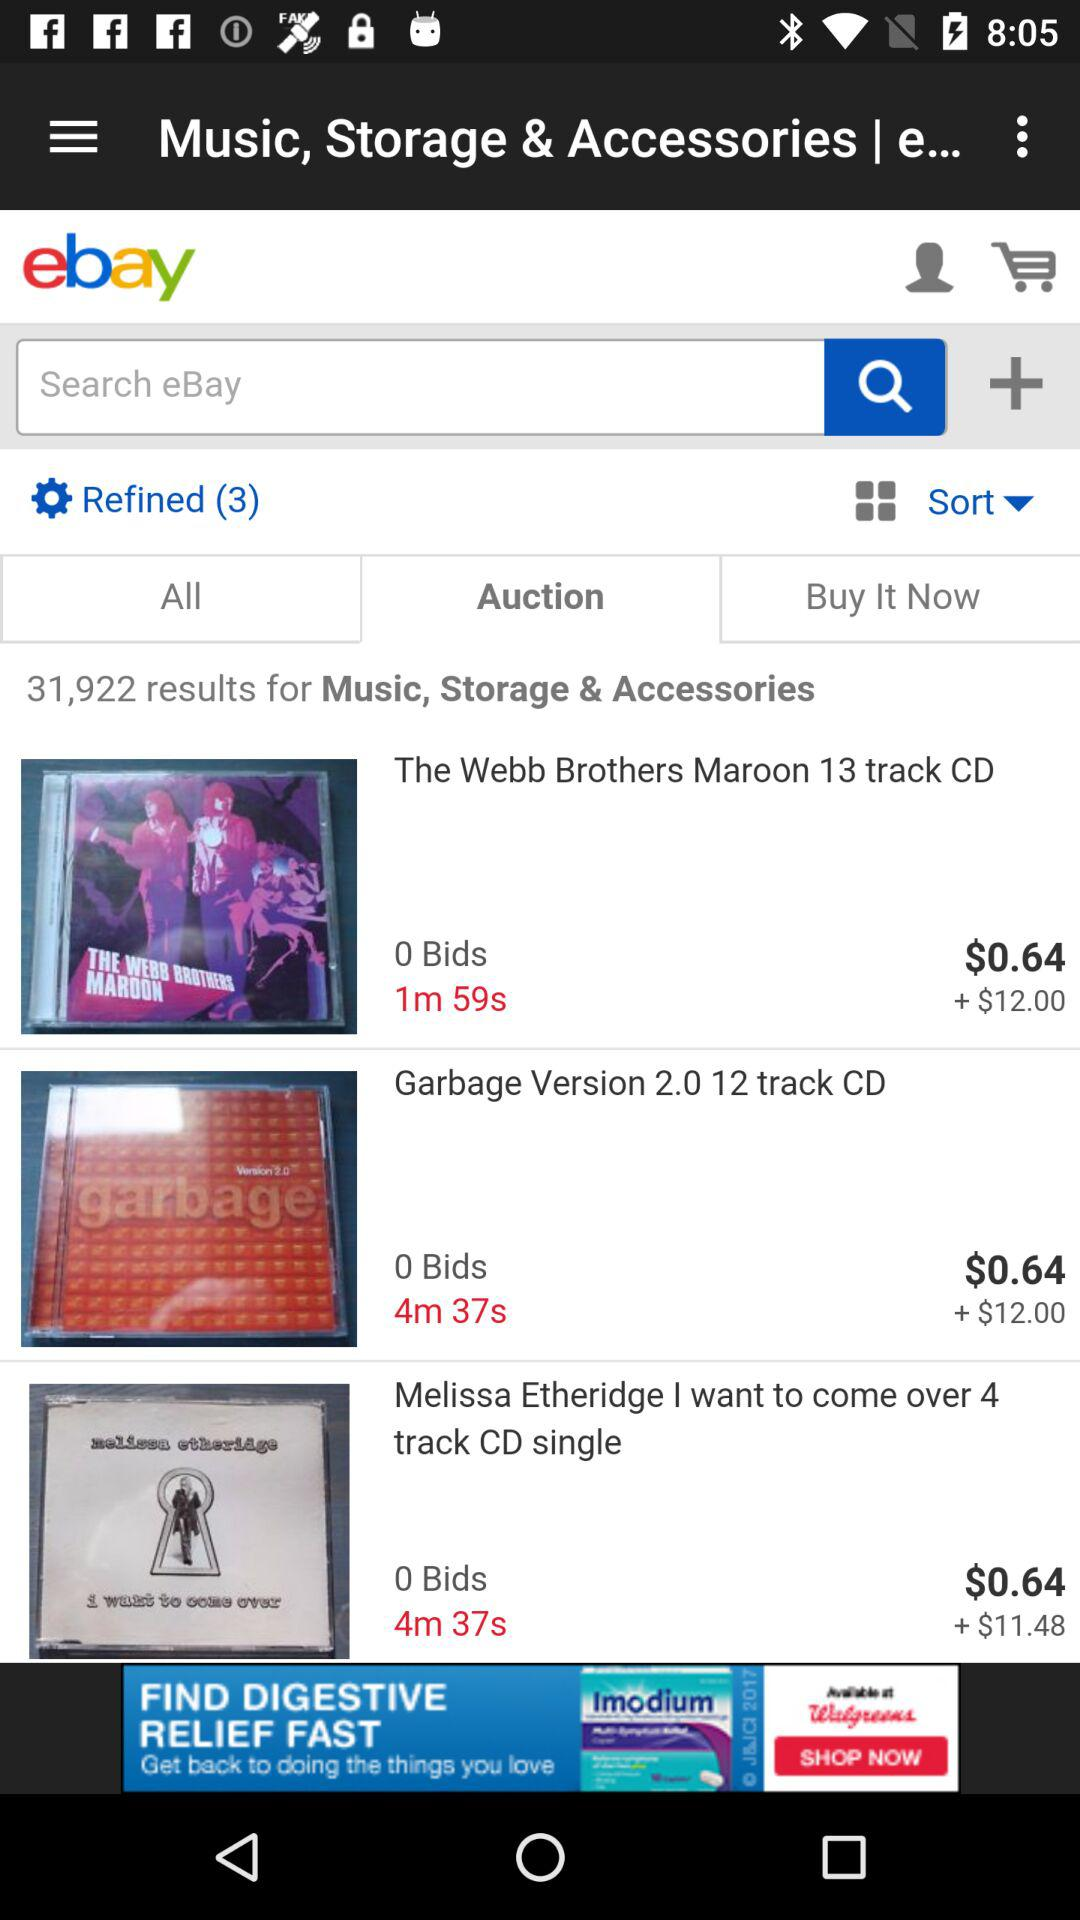How many results are there for "Music, Storage & Accessories"? There are 31,922 results for "Music, Storage & Accessories". 